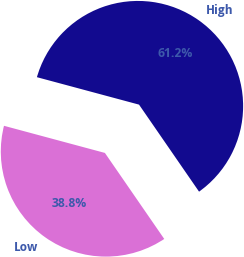Convert chart. <chart><loc_0><loc_0><loc_500><loc_500><pie_chart><fcel>High<fcel>Low<nl><fcel>61.21%<fcel>38.79%<nl></chart> 